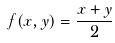<formula> <loc_0><loc_0><loc_500><loc_500>f ( x , y ) = \frac { x + y } { 2 }</formula> 